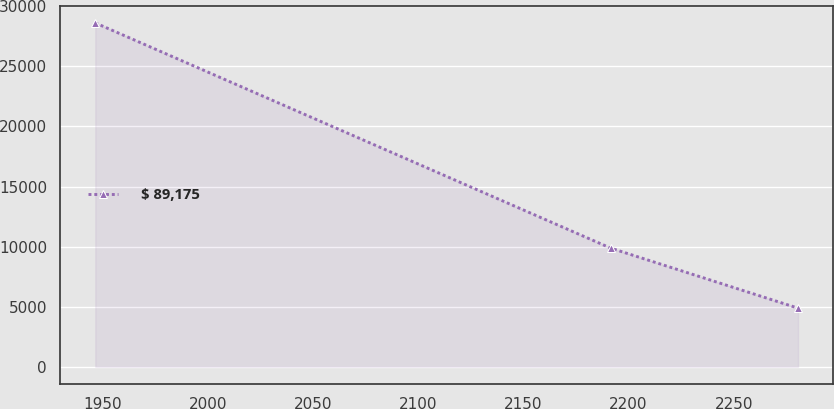Convert chart. <chart><loc_0><loc_0><loc_500><loc_500><line_chart><ecel><fcel>$ 89,175<nl><fcel>1946.52<fcel>28618.4<nl><fcel>2191.61<fcel>9872.84<nl><fcel>2280.61<fcel>4882.42<nl></chart> 